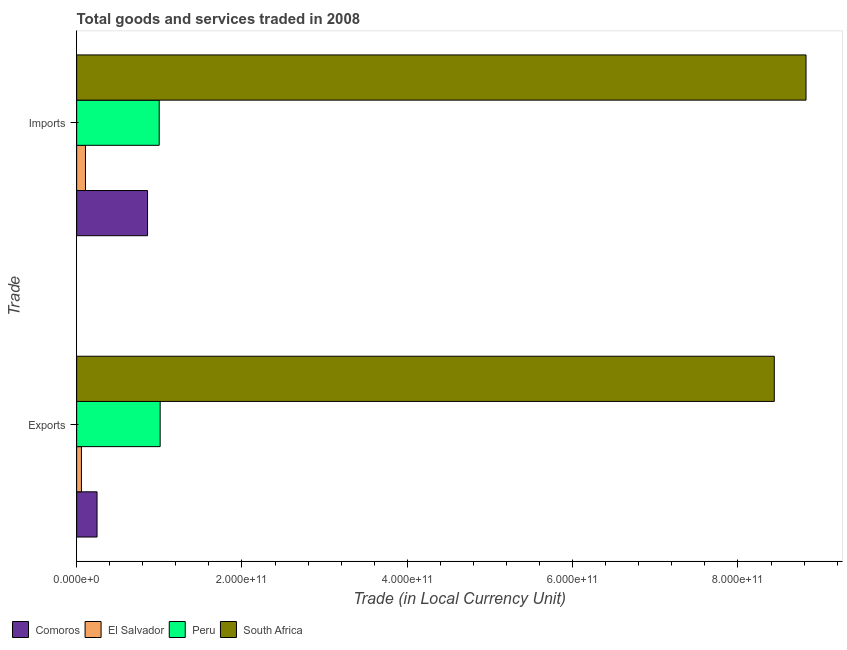How many groups of bars are there?
Provide a succinct answer. 2. Are the number of bars on each tick of the Y-axis equal?
Make the answer very short. Yes. How many bars are there on the 2nd tick from the top?
Your answer should be compact. 4. How many bars are there on the 1st tick from the bottom?
Offer a terse response. 4. What is the label of the 2nd group of bars from the top?
Keep it short and to the point. Exports. What is the export of goods and services in South Africa?
Offer a very short reply. 8.44e+11. Across all countries, what is the maximum imports of goods and services?
Provide a succinct answer. 8.82e+11. Across all countries, what is the minimum imports of goods and services?
Ensure brevity in your answer.  1.07e+1. In which country was the imports of goods and services maximum?
Ensure brevity in your answer.  South Africa. In which country was the export of goods and services minimum?
Your response must be concise. El Salvador. What is the total export of goods and services in the graph?
Your answer should be compact. 9.75e+11. What is the difference between the imports of goods and services in Peru and that in Comoros?
Your answer should be very brief. 1.41e+1. What is the difference between the export of goods and services in El Salvador and the imports of goods and services in South Africa?
Your answer should be compact. -8.77e+11. What is the average imports of goods and services per country?
Provide a succinct answer. 2.70e+11. What is the difference between the imports of goods and services and export of goods and services in Comoros?
Your response must be concise. 6.11e+1. What is the ratio of the export of goods and services in Peru to that in Comoros?
Provide a succinct answer. 4.09. Is the export of goods and services in South Africa less than that in El Salvador?
Your answer should be compact. No. In how many countries, is the imports of goods and services greater than the average imports of goods and services taken over all countries?
Ensure brevity in your answer.  1. What does the 3rd bar from the top in Exports represents?
Offer a very short reply. El Salvador. What does the 2nd bar from the bottom in Exports represents?
Offer a terse response. El Salvador. How many bars are there?
Ensure brevity in your answer.  8. Are all the bars in the graph horizontal?
Give a very brief answer. Yes. What is the difference between two consecutive major ticks on the X-axis?
Your answer should be very brief. 2.00e+11. Are the values on the major ticks of X-axis written in scientific E-notation?
Provide a succinct answer. Yes. Does the graph contain any zero values?
Provide a succinct answer. No. Does the graph contain grids?
Offer a very short reply. No. Where does the legend appear in the graph?
Your response must be concise. Bottom left. What is the title of the graph?
Make the answer very short. Total goods and services traded in 2008. Does "Guinea" appear as one of the legend labels in the graph?
Make the answer very short. No. What is the label or title of the X-axis?
Provide a succinct answer. Trade (in Local Currency Unit). What is the label or title of the Y-axis?
Provide a short and direct response. Trade. What is the Trade (in Local Currency Unit) of Comoros in Exports?
Offer a very short reply. 2.47e+1. What is the Trade (in Local Currency Unit) of El Salvador in Exports?
Offer a terse response. 5.76e+09. What is the Trade (in Local Currency Unit) in Peru in Exports?
Offer a very short reply. 1.01e+11. What is the Trade (in Local Currency Unit) of South Africa in Exports?
Provide a short and direct response. 8.44e+11. What is the Trade (in Local Currency Unit) of Comoros in Imports?
Offer a very short reply. 8.58e+1. What is the Trade (in Local Currency Unit) of El Salvador in Imports?
Your response must be concise. 1.07e+1. What is the Trade (in Local Currency Unit) of Peru in Imports?
Offer a terse response. 9.99e+1. What is the Trade (in Local Currency Unit) of South Africa in Imports?
Your answer should be very brief. 8.82e+11. Across all Trade, what is the maximum Trade (in Local Currency Unit) in Comoros?
Your answer should be very brief. 8.58e+1. Across all Trade, what is the maximum Trade (in Local Currency Unit) in El Salvador?
Your answer should be very brief. 1.07e+1. Across all Trade, what is the maximum Trade (in Local Currency Unit) of Peru?
Give a very brief answer. 1.01e+11. Across all Trade, what is the maximum Trade (in Local Currency Unit) of South Africa?
Give a very brief answer. 8.82e+11. Across all Trade, what is the minimum Trade (in Local Currency Unit) of Comoros?
Provide a succinct answer. 2.47e+1. Across all Trade, what is the minimum Trade (in Local Currency Unit) of El Salvador?
Provide a succinct answer. 5.76e+09. Across all Trade, what is the minimum Trade (in Local Currency Unit) of Peru?
Keep it short and to the point. 9.99e+1. Across all Trade, what is the minimum Trade (in Local Currency Unit) in South Africa?
Ensure brevity in your answer.  8.44e+11. What is the total Trade (in Local Currency Unit) in Comoros in the graph?
Make the answer very short. 1.10e+11. What is the total Trade (in Local Currency Unit) in El Salvador in the graph?
Provide a succinct answer. 1.64e+1. What is the total Trade (in Local Currency Unit) of Peru in the graph?
Offer a very short reply. 2.01e+11. What is the total Trade (in Local Currency Unit) of South Africa in the graph?
Make the answer very short. 1.73e+12. What is the difference between the Trade (in Local Currency Unit) in Comoros in Exports and that in Imports?
Provide a succinct answer. -6.11e+1. What is the difference between the Trade (in Local Currency Unit) in El Salvador in Exports and that in Imports?
Your response must be concise. -4.89e+09. What is the difference between the Trade (in Local Currency Unit) of Peru in Exports and that in Imports?
Your answer should be compact. 1.14e+09. What is the difference between the Trade (in Local Currency Unit) in South Africa in Exports and that in Imports?
Offer a very short reply. -3.84e+1. What is the difference between the Trade (in Local Currency Unit) of Comoros in Exports and the Trade (in Local Currency Unit) of El Salvador in Imports?
Keep it short and to the point. 1.40e+1. What is the difference between the Trade (in Local Currency Unit) of Comoros in Exports and the Trade (in Local Currency Unit) of Peru in Imports?
Make the answer very short. -7.52e+1. What is the difference between the Trade (in Local Currency Unit) of Comoros in Exports and the Trade (in Local Currency Unit) of South Africa in Imports?
Provide a succinct answer. -8.58e+11. What is the difference between the Trade (in Local Currency Unit) of El Salvador in Exports and the Trade (in Local Currency Unit) of Peru in Imports?
Make the answer very short. -9.41e+1. What is the difference between the Trade (in Local Currency Unit) in El Salvador in Exports and the Trade (in Local Currency Unit) in South Africa in Imports?
Ensure brevity in your answer.  -8.77e+11. What is the difference between the Trade (in Local Currency Unit) of Peru in Exports and the Trade (in Local Currency Unit) of South Africa in Imports?
Offer a terse response. -7.81e+11. What is the average Trade (in Local Currency Unit) of Comoros per Trade?
Provide a short and direct response. 5.52e+1. What is the average Trade (in Local Currency Unit) of El Salvador per Trade?
Make the answer very short. 8.21e+09. What is the average Trade (in Local Currency Unit) of Peru per Trade?
Your answer should be very brief. 1.00e+11. What is the average Trade (in Local Currency Unit) of South Africa per Trade?
Offer a terse response. 8.63e+11. What is the difference between the Trade (in Local Currency Unit) of Comoros and Trade (in Local Currency Unit) of El Salvador in Exports?
Make the answer very short. 1.89e+1. What is the difference between the Trade (in Local Currency Unit) in Comoros and Trade (in Local Currency Unit) in Peru in Exports?
Keep it short and to the point. -7.63e+1. What is the difference between the Trade (in Local Currency Unit) of Comoros and Trade (in Local Currency Unit) of South Africa in Exports?
Offer a terse response. -8.19e+11. What is the difference between the Trade (in Local Currency Unit) in El Salvador and Trade (in Local Currency Unit) in Peru in Exports?
Your answer should be very brief. -9.52e+1. What is the difference between the Trade (in Local Currency Unit) of El Salvador and Trade (in Local Currency Unit) of South Africa in Exports?
Your answer should be very brief. -8.38e+11. What is the difference between the Trade (in Local Currency Unit) in Peru and Trade (in Local Currency Unit) in South Africa in Exports?
Ensure brevity in your answer.  -7.43e+11. What is the difference between the Trade (in Local Currency Unit) of Comoros and Trade (in Local Currency Unit) of El Salvador in Imports?
Give a very brief answer. 7.51e+1. What is the difference between the Trade (in Local Currency Unit) in Comoros and Trade (in Local Currency Unit) in Peru in Imports?
Your answer should be very brief. -1.41e+1. What is the difference between the Trade (in Local Currency Unit) of Comoros and Trade (in Local Currency Unit) of South Africa in Imports?
Provide a short and direct response. -7.97e+11. What is the difference between the Trade (in Local Currency Unit) in El Salvador and Trade (in Local Currency Unit) in Peru in Imports?
Your answer should be compact. -8.92e+1. What is the difference between the Trade (in Local Currency Unit) of El Salvador and Trade (in Local Currency Unit) of South Africa in Imports?
Provide a succinct answer. -8.72e+11. What is the difference between the Trade (in Local Currency Unit) in Peru and Trade (in Local Currency Unit) in South Africa in Imports?
Offer a very short reply. -7.82e+11. What is the ratio of the Trade (in Local Currency Unit) in Comoros in Exports to that in Imports?
Make the answer very short. 0.29. What is the ratio of the Trade (in Local Currency Unit) of El Salvador in Exports to that in Imports?
Make the answer very short. 0.54. What is the ratio of the Trade (in Local Currency Unit) in Peru in Exports to that in Imports?
Give a very brief answer. 1.01. What is the ratio of the Trade (in Local Currency Unit) in South Africa in Exports to that in Imports?
Your answer should be very brief. 0.96. What is the difference between the highest and the second highest Trade (in Local Currency Unit) in Comoros?
Offer a terse response. 6.11e+1. What is the difference between the highest and the second highest Trade (in Local Currency Unit) in El Salvador?
Provide a short and direct response. 4.89e+09. What is the difference between the highest and the second highest Trade (in Local Currency Unit) of Peru?
Offer a terse response. 1.14e+09. What is the difference between the highest and the second highest Trade (in Local Currency Unit) of South Africa?
Your answer should be compact. 3.84e+1. What is the difference between the highest and the lowest Trade (in Local Currency Unit) in Comoros?
Give a very brief answer. 6.11e+1. What is the difference between the highest and the lowest Trade (in Local Currency Unit) of El Salvador?
Ensure brevity in your answer.  4.89e+09. What is the difference between the highest and the lowest Trade (in Local Currency Unit) of Peru?
Your response must be concise. 1.14e+09. What is the difference between the highest and the lowest Trade (in Local Currency Unit) in South Africa?
Offer a very short reply. 3.84e+1. 